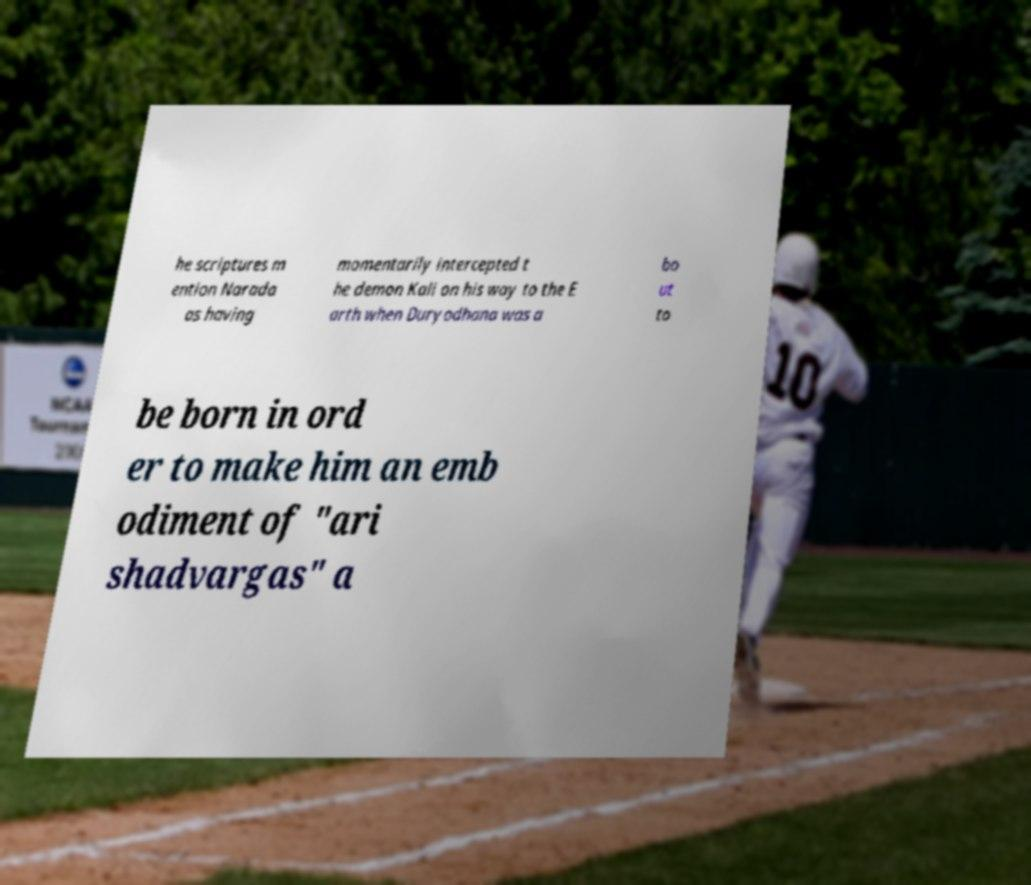What messages or text are displayed in this image? I need them in a readable, typed format. he scriptures m ention Narada as having momentarily intercepted t he demon Kali on his way to the E arth when Duryodhana was a bo ut to be born in ord er to make him an emb odiment of "ari shadvargas" a 